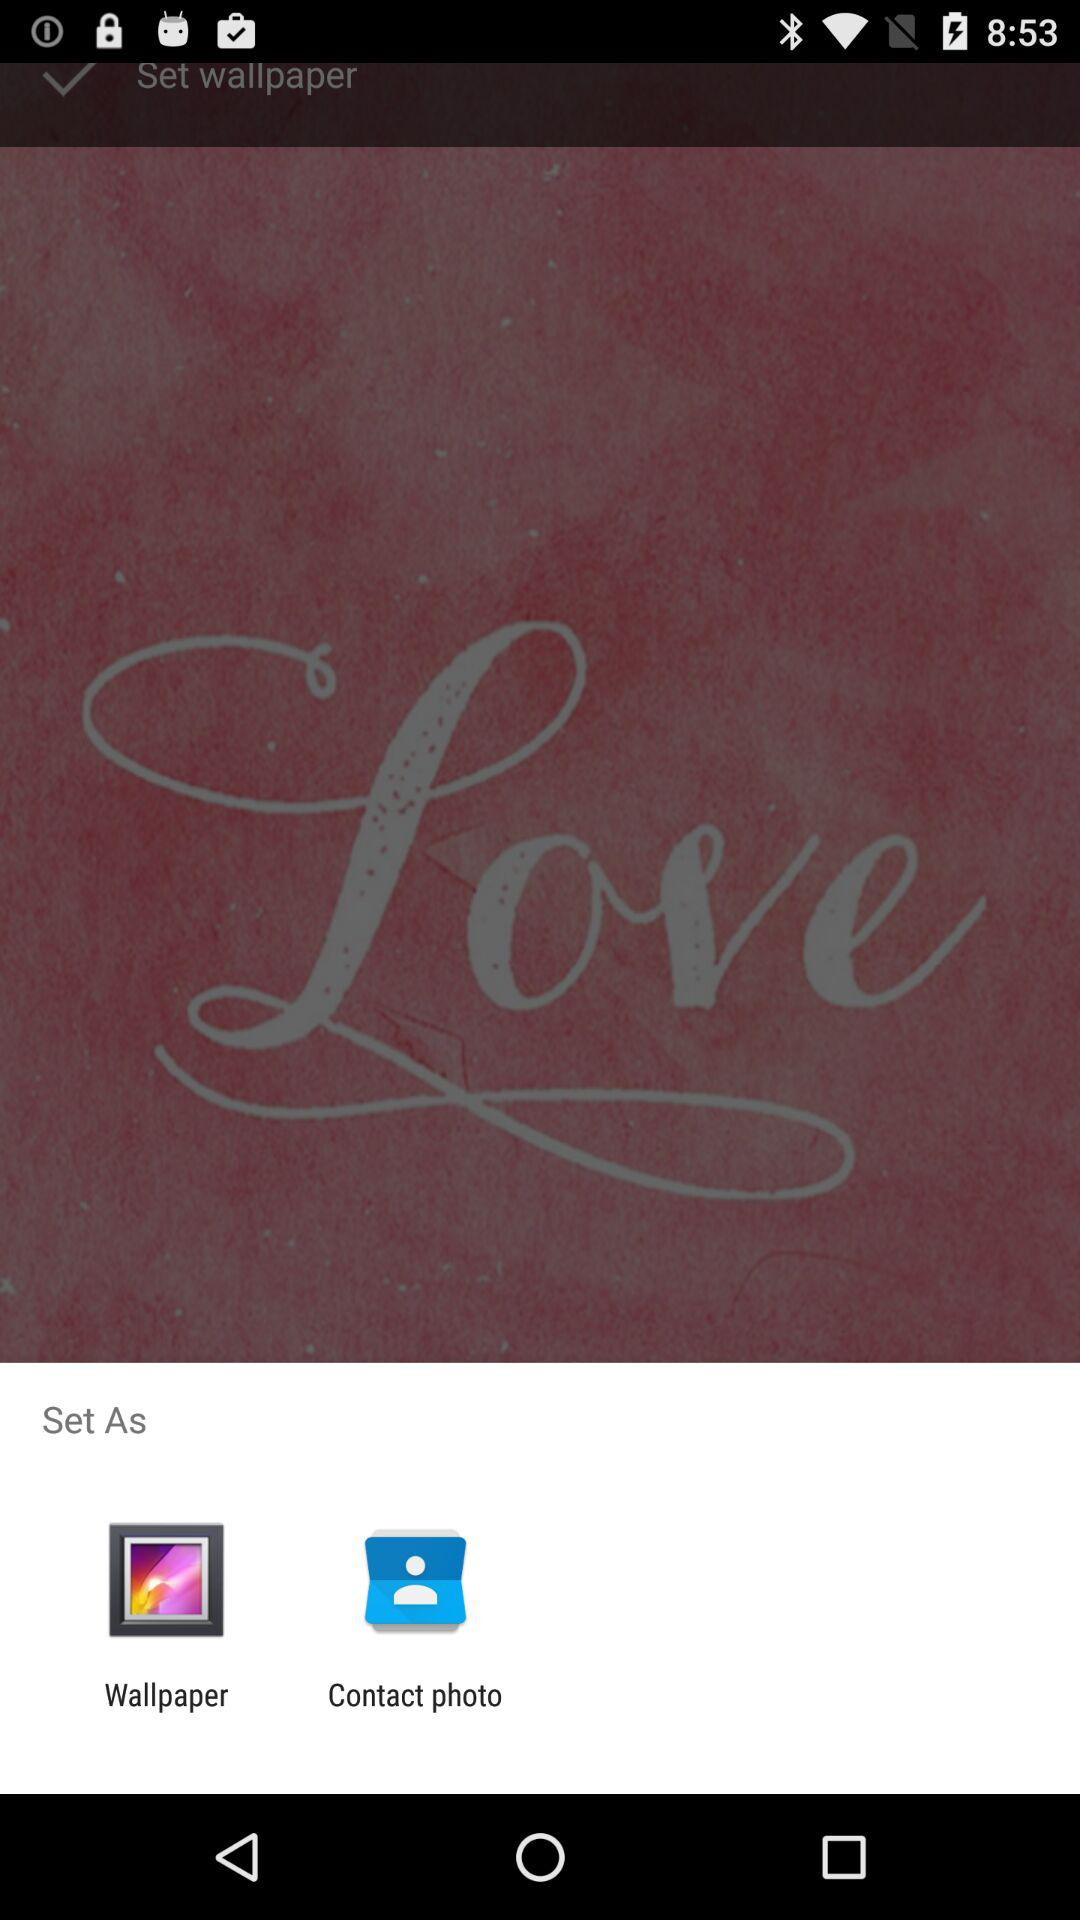What is the name of the application?
When the provided information is insufficient, respond with <no answer>. <no answer> 